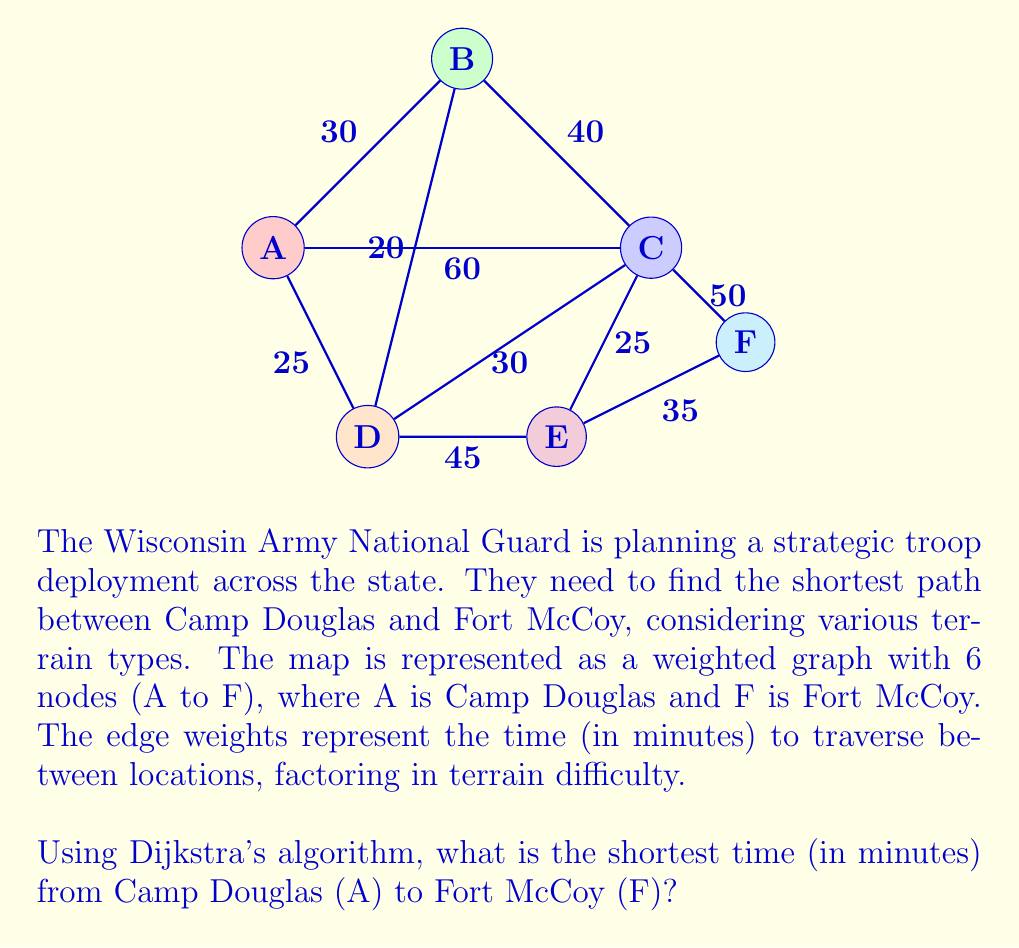Can you solve this math problem? Let's apply Dijkstra's algorithm step by step:

1) Initialize:
   - Set distance to A as 0, all others as infinity
   - Set all nodes as unvisited
   - Set A as the current node

2) For the current node, calculate distances to unvisited neighbors:
   - A to B: 0 + 30 = 30
   - A to C: 0 + 60 = 60
   - A to D: 0 + 25 = 25

3) Update distances if shorter path found, mark A as visited

4) Select the unvisited node with the smallest distance (D) as the new current node

5) Repeat steps 2-4:
   - From D:
     D to B: 25 + 20 = 45
     D to C: 25 + 30 = 55 (shorter than current 60)
     D to E: 25 + 45 = 70
   - From B:
     B to C: 30 + 40 = 70 (not shorter)
   - From C:
     C to E: 55 + 25 = 80
     C to F: 55 + 50 = 105
   - From E:
     E to F: 70 + 35 = 105 (same as current)

6) The algorithm terminates when F is reached

The shortest path is A → D → C → F, with a total time of 105 minutes.
Answer: 105 minutes 